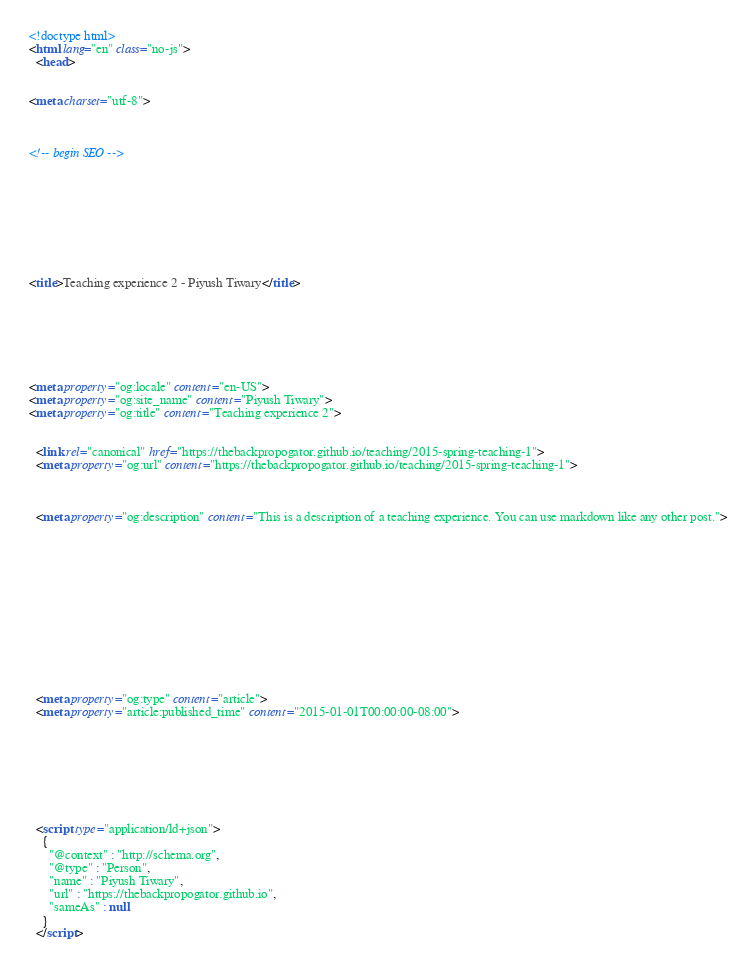Convert code to text. <code><loc_0><loc_0><loc_500><loc_500><_HTML_>

<!doctype html>
<html lang="en" class="no-js">
  <head>
    

<meta charset="utf-8">



<!-- begin SEO -->









<title>Teaching experience 2 - Piyush Tiwary</title>







<meta property="og:locale" content="en-US">
<meta property="og:site_name" content="Piyush Tiwary">
<meta property="og:title" content="Teaching experience 2">


  <link rel="canonical" href="https://thebackpropogator.github.io/teaching/2015-spring-teaching-1">
  <meta property="og:url" content="https://thebackpropogator.github.io/teaching/2015-spring-teaching-1">



  <meta property="og:description" content="This is a description of a teaching experience. You can use markdown like any other post.">





  

  





  <meta property="og:type" content="article">
  <meta property="article:published_time" content="2015-01-01T00:00:00-08:00">








  <script type="application/ld+json">
    {
      "@context" : "http://schema.org",
      "@type" : "Person",
      "name" : "Piyush Tiwary",
      "url" : "https://thebackpropogator.github.io",
      "sameAs" : null
    }
  </script>





</code> 